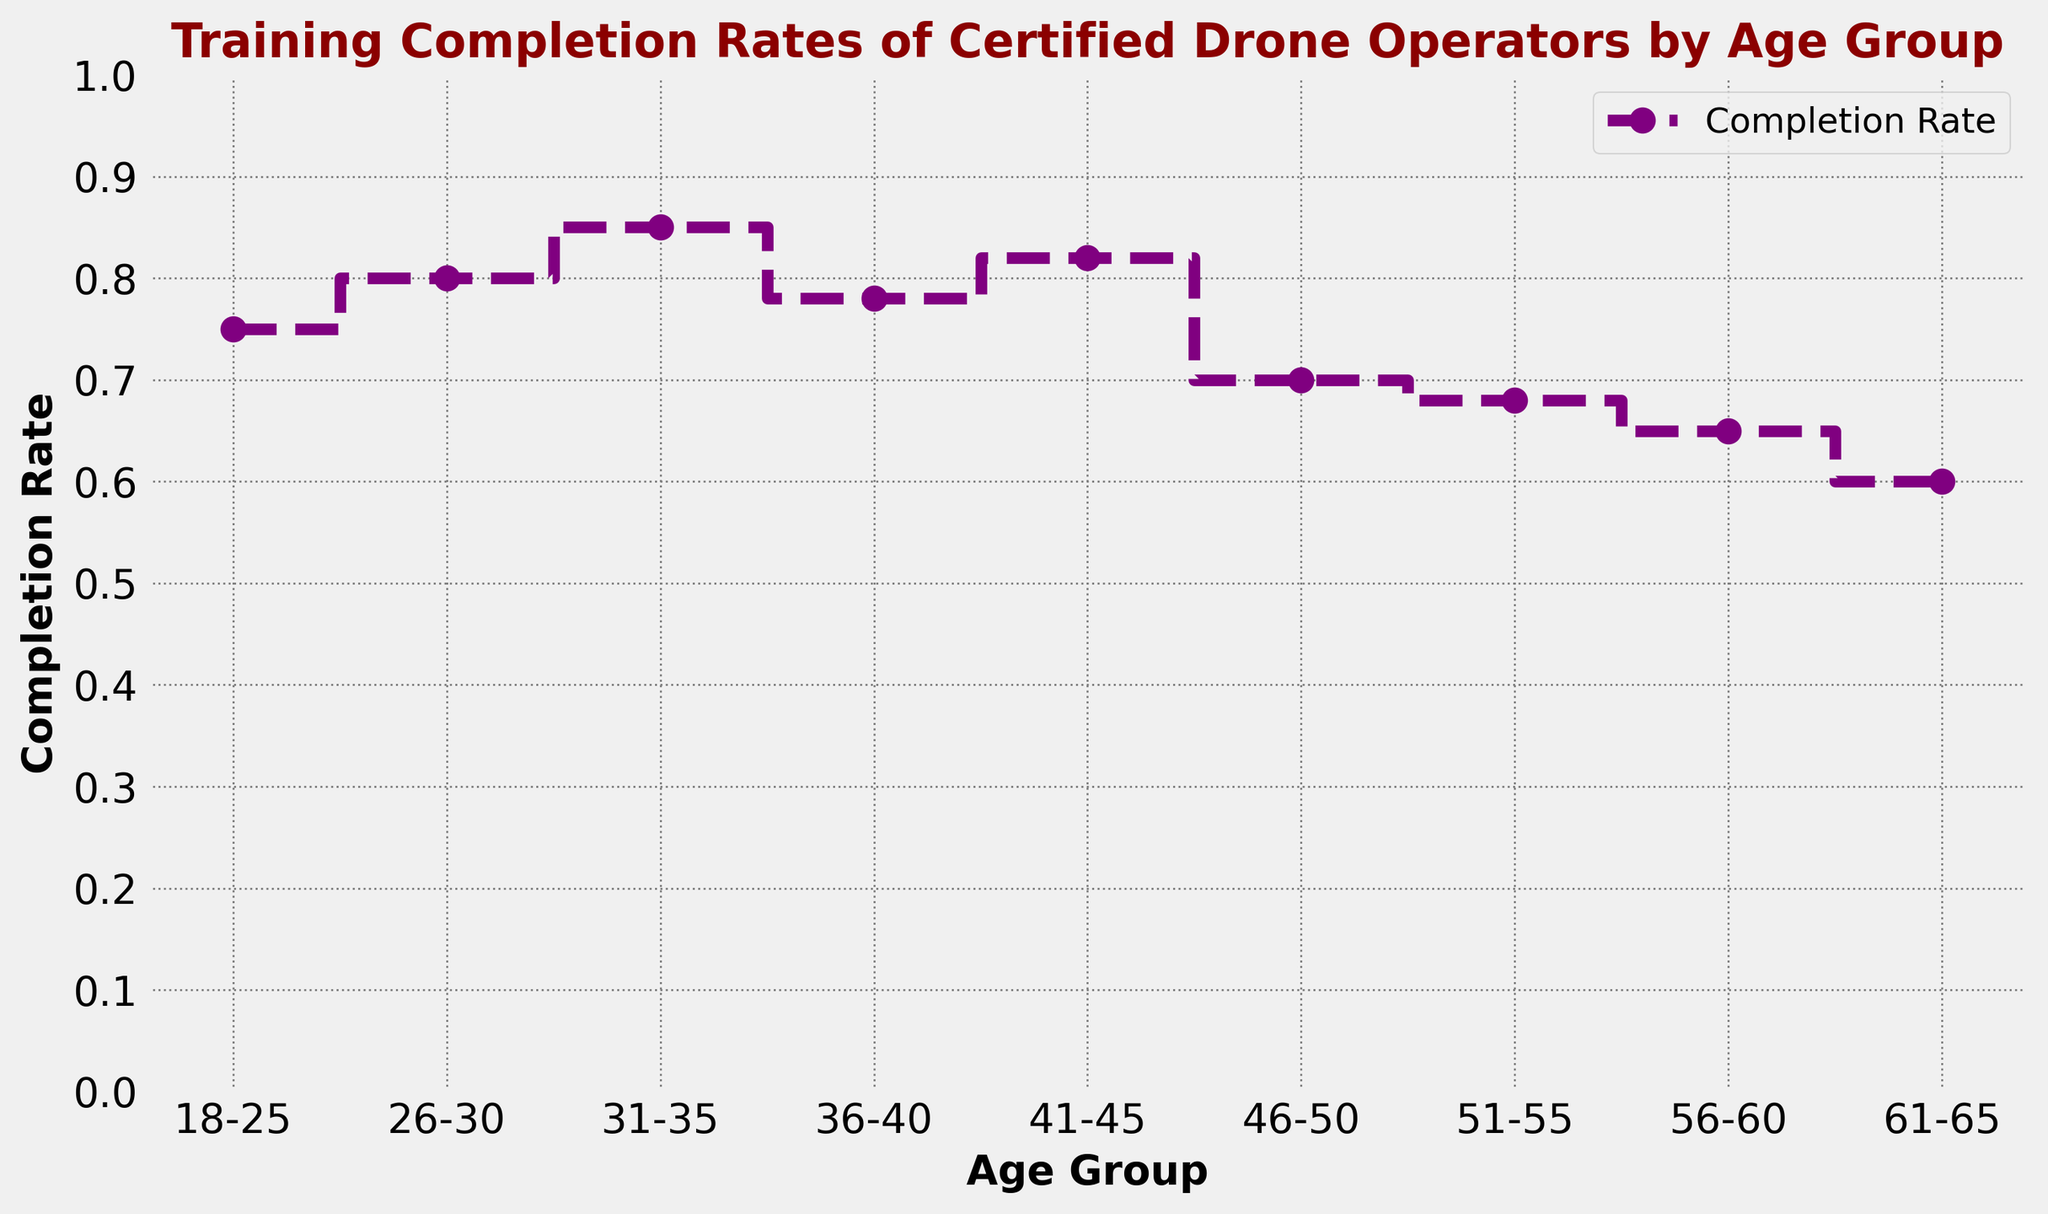What is the completion rate for the 26-30 age group? The plot shows data points with markers representing different age groups. Locate the marker for the 26-30 age group on the x-axis and read the corresponding value on the y-axis.
Answer: 0.80 Which age group has the highest completion rate? Examine the plot to find the peak of the stairs plot, which visually represents the highest point. The age group associated with this point is the one with the highest completion rate.
Answer: 31-35 Is the completion rate for the 46-50 age group higher or lower than that of the 41-45 age group? Identify the markers for both the 46-50 and 41-45 age groups on the x-axis and compare their corresponding y-axis values.
Answer: Lower How does the completion rate change from the 51-55 age group to the 56-60 age group? Locate the markers for both the 51-55 and 56-60 age groups and compare their y-axis values to see if there is an increase or decrease.
Answer: Decrease What are the average completion rates of the age groups from 18-25 and 26-30? Identify the y-axis values for the 18-25 and 26-30 age groups, add them together, and divide by 2 to find the average. (0.75 + 0.80) / 2 = 0.775
Answer: 0.775 Which has a higher completion rate: 36-40 or 51-55 age group? Compare the y-axis values of the markers for the 36-40 age group and the 51-55 age group.
Answer: 36-40 What is the completion rate difference between the 31-35 and 61-65 age groups? Find the y-axis values for both age groups and calculate the difference by subtracting the value of the 61-65 group from the 31-35 group. 0.85 - 0.60 = 0.25
Answer: 0.25 Does the completion rate trend appear to increase, decrease, or fluctuate with age? Observing the overall shape of the plot, one can see the pattern in which the rates change across age groups. The plot shows a general decrease but does have fluctuations.
Answer: Decrease with fluctuations 